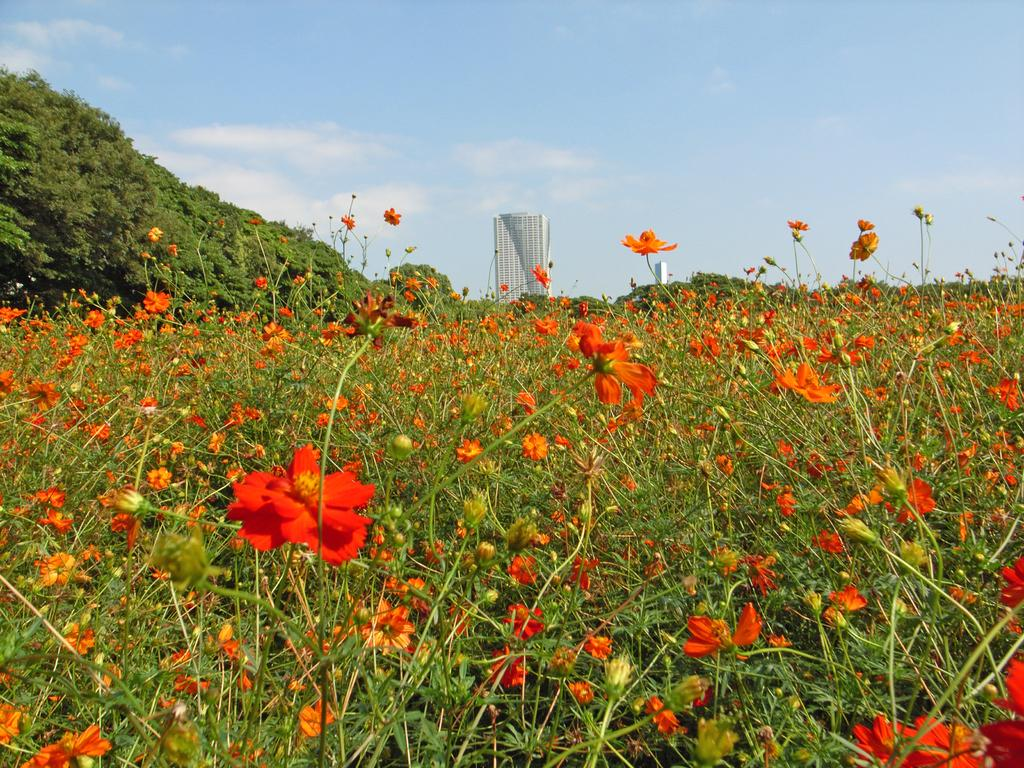What type of vegetation is at the bottom of the image? There are flower plants at the bottom of the image. What can be seen on the left side of the image? There are trees on the left side of the image. What structure is located in the middle of the image? There is a building in the middle of the image. What is visible in the background of the image? The sky is visible in the background of the image. What type of gold object is present in the image? There is no gold object present in the image. Can you see a fireman in the image? There is no fireman depicted in the image. 